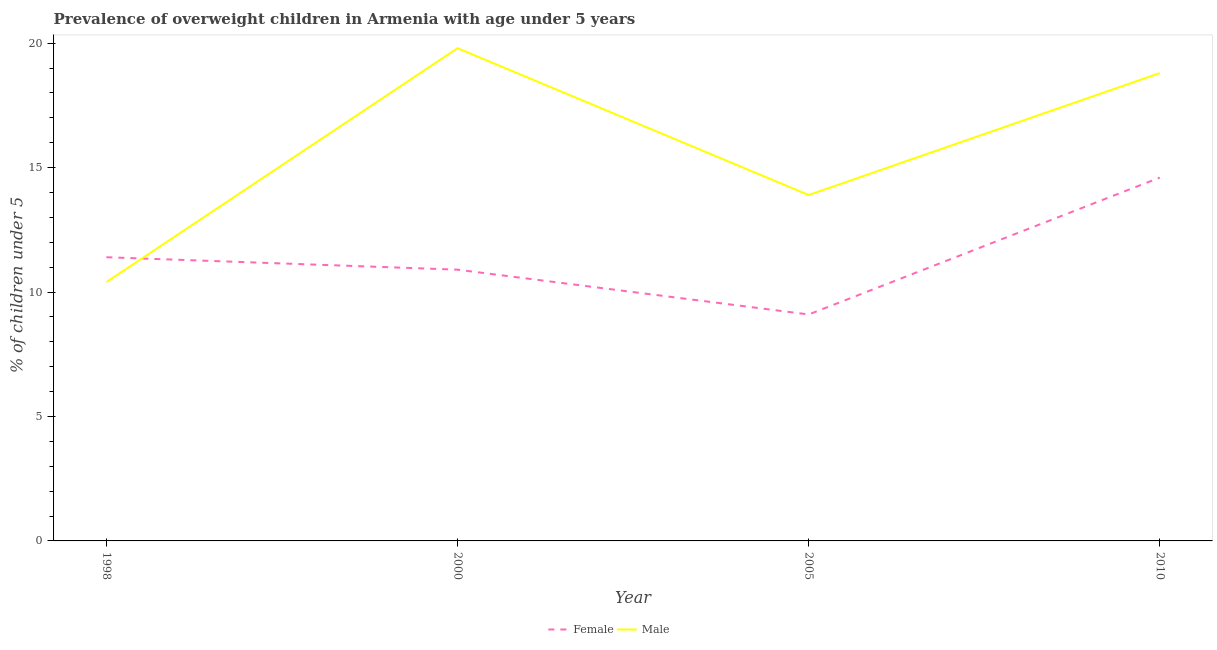How many different coloured lines are there?
Your response must be concise. 2. What is the percentage of obese female children in 2005?
Make the answer very short. 9.1. Across all years, what is the maximum percentage of obese male children?
Offer a very short reply. 19.8. Across all years, what is the minimum percentage of obese female children?
Your answer should be compact. 9.1. In which year was the percentage of obese female children minimum?
Give a very brief answer. 2005. What is the total percentage of obese female children in the graph?
Give a very brief answer. 46. What is the difference between the percentage of obese female children in 2000 and that in 2005?
Make the answer very short. 1.8. What is the average percentage of obese female children per year?
Your response must be concise. 11.5. In the year 2005, what is the difference between the percentage of obese female children and percentage of obese male children?
Offer a very short reply. -4.8. In how many years, is the percentage of obese female children greater than 3 %?
Make the answer very short. 4. What is the ratio of the percentage of obese female children in 2005 to that in 2010?
Your answer should be compact. 0.62. What is the difference between the highest and the second highest percentage of obese female children?
Offer a terse response. 3.2. What is the difference between the highest and the lowest percentage of obese female children?
Your response must be concise. 5.5. In how many years, is the percentage of obese female children greater than the average percentage of obese female children taken over all years?
Provide a succinct answer. 1. Is the sum of the percentage of obese male children in 2005 and 2010 greater than the maximum percentage of obese female children across all years?
Your answer should be very brief. Yes. Is the percentage of obese male children strictly less than the percentage of obese female children over the years?
Offer a very short reply. No. Does the graph contain any zero values?
Provide a succinct answer. No. Where does the legend appear in the graph?
Offer a very short reply. Bottom center. How many legend labels are there?
Ensure brevity in your answer.  2. What is the title of the graph?
Your answer should be compact. Prevalence of overweight children in Armenia with age under 5 years. What is the label or title of the X-axis?
Your answer should be compact. Year. What is the label or title of the Y-axis?
Your response must be concise.  % of children under 5. What is the  % of children under 5 in Female in 1998?
Provide a succinct answer. 11.4. What is the  % of children under 5 in Male in 1998?
Your response must be concise. 10.4. What is the  % of children under 5 of Female in 2000?
Provide a short and direct response. 10.9. What is the  % of children under 5 of Male in 2000?
Keep it short and to the point. 19.8. What is the  % of children under 5 in Female in 2005?
Keep it short and to the point. 9.1. What is the  % of children under 5 of Male in 2005?
Your answer should be compact. 13.9. What is the  % of children under 5 of Female in 2010?
Ensure brevity in your answer.  14.6. What is the  % of children under 5 of Male in 2010?
Keep it short and to the point. 18.8. Across all years, what is the maximum  % of children under 5 in Female?
Provide a succinct answer. 14.6. Across all years, what is the maximum  % of children under 5 of Male?
Offer a very short reply. 19.8. Across all years, what is the minimum  % of children under 5 in Female?
Your response must be concise. 9.1. Across all years, what is the minimum  % of children under 5 of Male?
Offer a very short reply. 10.4. What is the total  % of children under 5 of Male in the graph?
Provide a succinct answer. 62.9. What is the difference between the  % of children under 5 of Male in 1998 and that in 2000?
Give a very brief answer. -9.4. What is the difference between the  % of children under 5 in Female in 1998 and that in 2010?
Your response must be concise. -3.2. What is the difference between the  % of children under 5 in Male in 1998 and that in 2010?
Offer a terse response. -8.4. What is the difference between the  % of children under 5 of Female in 2000 and that in 2005?
Keep it short and to the point. 1.8. What is the difference between the  % of children under 5 of Male in 2000 and that in 2005?
Make the answer very short. 5.9. What is the difference between the  % of children under 5 of Female in 2000 and that in 2010?
Your answer should be compact. -3.7. What is the difference between the  % of children under 5 of Male in 2005 and that in 2010?
Keep it short and to the point. -4.9. What is the difference between the  % of children under 5 in Female in 1998 and the  % of children under 5 in Male in 2000?
Offer a very short reply. -8.4. What is the difference between the  % of children under 5 of Female in 2000 and the  % of children under 5 of Male in 2010?
Give a very brief answer. -7.9. What is the difference between the  % of children under 5 in Female in 2005 and the  % of children under 5 in Male in 2010?
Make the answer very short. -9.7. What is the average  % of children under 5 of Female per year?
Your answer should be very brief. 11.5. What is the average  % of children under 5 of Male per year?
Your answer should be compact. 15.72. In the year 1998, what is the difference between the  % of children under 5 of Female and  % of children under 5 of Male?
Provide a short and direct response. 1. In the year 2000, what is the difference between the  % of children under 5 of Female and  % of children under 5 of Male?
Give a very brief answer. -8.9. What is the ratio of the  % of children under 5 of Female in 1998 to that in 2000?
Ensure brevity in your answer.  1.05. What is the ratio of the  % of children under 5 of Male in 1998 to that in 2000?
Your answer should be compact. 0.53. What is the ratio of the  % of children under 5 in Female in 1998 to that in 2005?
Make the answer very short. 1.25. What is the ratio of the  % of children under 5 of Male in 1998 to that in 2005?
Provide a succinct answer. 0.75. What is the ratio of the  % of children under 5 of Female in 1998 to that in 2010?
Ensure brevity in your answer.  0.78. What is the ratio of the  % of children under 5 in Male in 1998 to that in 2010?
Provide a succinct answer. 0.55. What is the ratio of the  % of children under 5 in Female in 2000 to that in 2005?
Your answer should be compact. 1.2. What is the ratio of the  % of children under 5 in Male in 2000 to that in 2005?
Make the answer very short. 1.42. What is the ratio of the  % of children under 5 of Female in 2000 to that in 2010?
Offer a terse response. 0.75. What is the ratio of the  % of children under 5 in Male in 2000 to that in 2010?
Ensure brevity in your answer.  1.05. What is the ratio of the  % of children under 5 of Female in 2005 to that in 2010?
Provide a short and direct response. 0.62. What is the ratio of the  % of children under 5 of Male in 2005 to that in 2010?
Give a very brief answer. 0.74. What is the difference between the highest and the second highest  % of children under 5 in Female?
Your response must be concise. 3.2. What is the difference between the highest and the second highest  % of children under 5 in Male?
Ensure brevity in your answer.  1. What is the difference between the highest and the lowest  % of children under 5 of Female?
Provide a succinct answer. 5.5. 